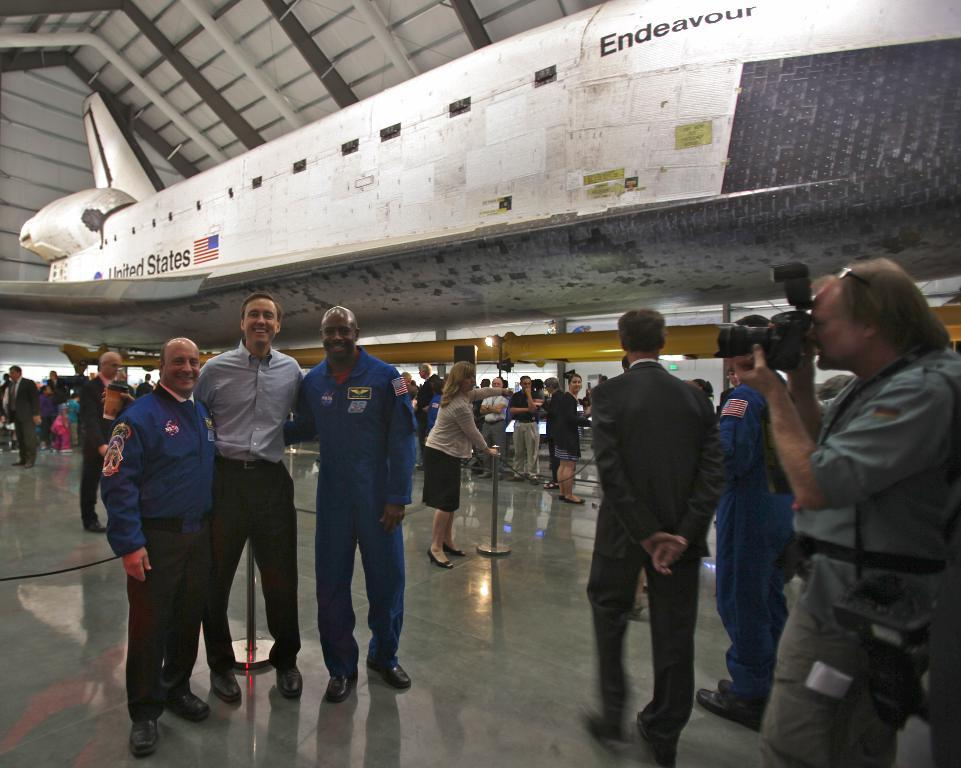<image>
Relay a brief, clear account of the picture shown. Endeavour airplane parked while people are looking at it. 